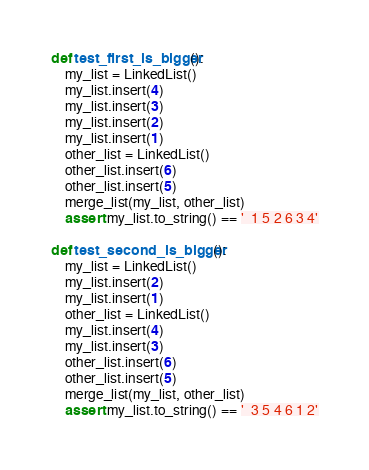<code> <loc_0><loc_0><loc_500><loc_500><_Python_>def test_first_is_bigger():
    my_list = LinkedList()
    my_list.insert(4)
    my_list.insert(3)
    my_list.insert(2)
    my_list.insert(1)
    other_list = LinkedList()
    other_list.insert(6)
    other_list.insert(5)
    merge_list(my_list, other_list)
    assert my_list.to_string() == '  1 5 2 6 3 4'

def test_second_is_bigger():
    my_list = LinkedList()
    my_list.insert(2)
    my_list.insert(1)
    other_list = LinkedList()
    my_list.insert(4)
    my_list.insert(3)
    other_list.insert(6)
    other_list.insert(5)
    merge_list(my_list, other_list)
    assert my_list.to_string() == '  3 5 4 6 1 2'</code> 